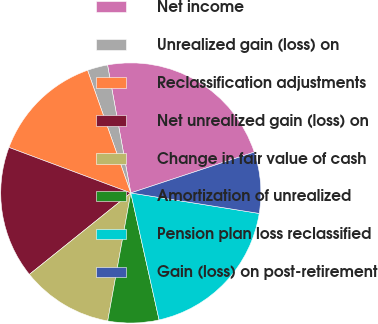Convert chart to OTSL. <chart><loc_0><loc_0><loc_500><loc_500><pie_chart><fcel>Net income<fcel>Unrealized gain (loss) on<fcel>Reclassification adjustments<fcel>Net unrealized gain (loss) on<fcel>Change in fair value of cash<fcel>Amortization of unrealized<fcel>Pension plan loss reclassified<fcel>Gain (loss) on post-retirement<nl><fcel>22.78%<fcel>2.53%<fcel>13.92%<fcel>16.46%<fcel>11.39%<fcel>6.33%<fcel>18.99%<fcel>7.6%<nl></chart> 